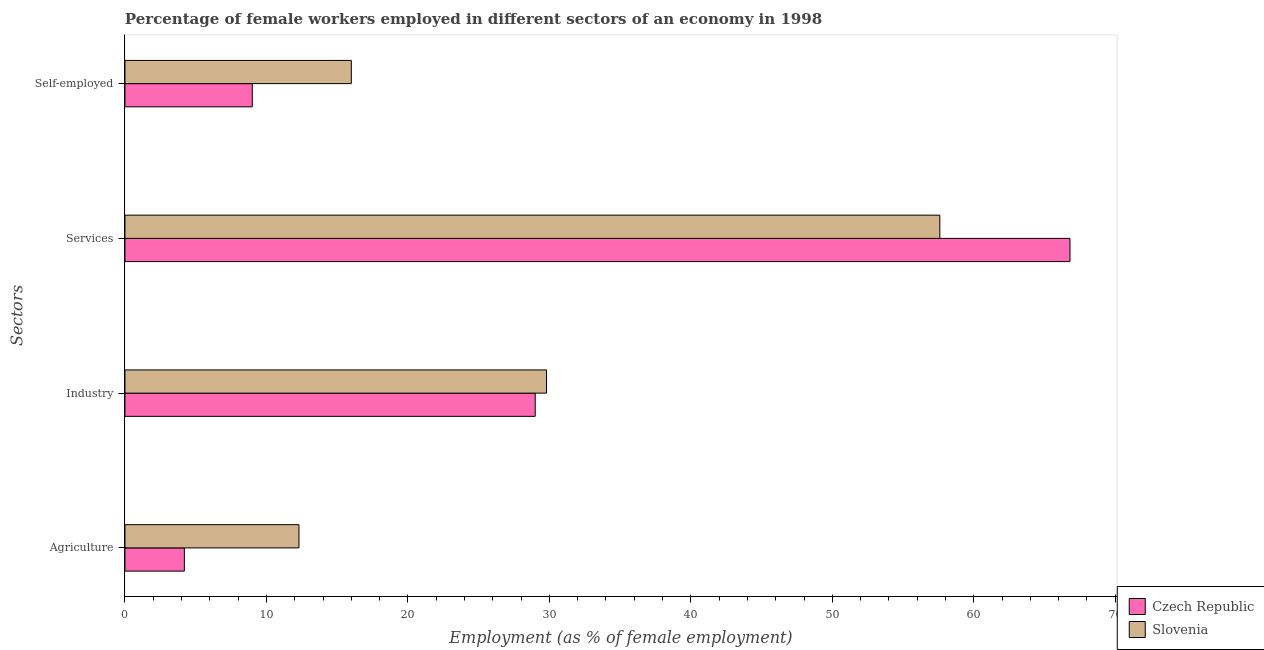How many groups of bars are there?
Offer a terse response. 4. How many bars are there on the 4th tick from the top?
Make the answer very short. 2. How many bars are there on the 3rd tick from the bottom?
Offer a terse response. 2. What is the label of the 4th group of bars from the top?
Make the answer very short. Agriculture. What is the percentage of self employed female workers in Czech Republic?
Your answer should be very brief. 9. Across all countries, what is the maximum percentage of self employed female workers?
Make the answer very short. 16. Across all countries, what is the minimum percentage of female workers in services?
Offer a very short reply. 57.6. In which country was the percentage of female workers in services maximum?
Keep it short and to the point. Czech Republic. In which country was the percentage of female workers in services minimum?
Provide a succinct answer. Slovenia. What is the total percentage of female workers in services in the graph?
Ensure brevity in your answer.  124.4. What is the difference between the percentage of female workers in industry in Slovenia and that in Czech Republic?
Offer a very short reply. 0.8. What is the difference between the percentage of female workers in industry in Czech Republic and the percentage of female workers in agriculture in Slovenia?
Your response must be concise. 16.7. What is the average percentage of self employed female workers per country?
Ensure brevity in your answer.  12.5. What is the difference between the percentage of female workers in industry and percentage of female workers in agriculture in Slovenia?
Provide a succinct answer. 17.5. What is the ratio of the percentage of female workers in industry in Czech Republic to that in Slovenia?
Offer a terse response. 0.97. Is the difference between the percentage of female workers in services in Slovenia and Czech Republic greater than the difference between the percentage of female workers in industry in Slovenia and Czech Republic?
Keep it short and to the point. No. What is the difference between the highest and the second highest percentage of female workers in agriculture?
Your answer should be very brief. 8.1. What is the difference between the highest and the lowest percentage of female workers in services?
Your answer should be compact. 9.2. What does the 2nd bar from the top in Services represents?
Ensure brevity in your answer.  Czech Republic. What does the 2nd bar from the bottom in Agriculture represents?
Your answer should be very brief. Slovenia. Is it the case that in every country, the sum of the percentage of female workers in agriculture and percentage of female workers in industry is greater than the percentage of female workers in services?
Make the answer very short. No. Are all the bars in the graph horizontal?
Offer a very short reply. Yes. Are the values on the major ticks of X-axis written in scientific E-notation?
Ensure brevity in your answer.  No. Does the graph contain any zero values?
Make the answer very short. No. Does the graph contain grids?
Keep it short and to the point. No. How are the legend labels stacked?
Keep it short and to the point. Vertical. What is the title of the graph?
Give a very brief answer. Percentage of female workers employed in different sectors of an economy in 1998. Does "Belize" appear as one of the legend labels in the graph?
Make the answer very short. No. What is the label or title of the X-axis?
Ensure brevity in your answer.  Employment (as % of female employment). What is the label or title of the Y-axis?
Provide a succinct answer. Sectors. What is the Employment (as % of female employment) of Czech Republic in Agriculture?
Offer a terse response. 4.2. What is the Employment (as % of female employment) in Slovenia in Agriculture?
Give a very brief answer. 12.3. What is the Employment (as % of female employment) of Czech Republic in Industry?
Make the answer very short. 29. What is the Employment (as % of female employment) in Slovenia in Industry?
Offer a terse response. 29.8. What is the Employment (as % of female employment) of Czech Republic in Services?
Offer a very short reply. 66.8. What is the Employment (as % of female employment) in Slovenia in Services?
Make the answer very short. 57.6. What is the Employment (as % of female employment) in Czech Republic in Self-employed?
Make the answer very short. 9. Across all Sectors, what is the maximum Employment (as % of female employment) in Czech Republic?
Your answer should be compact. 66.8. Across all Sectors, what is the maximum Employment (as % of female employment) in Slovenia?
Make the answer very short. 57.6. Across all Sectors, what is the minimum Employment (as % of female employment) in Czech Republic?
Provide a short and direct response. 4.2. Across all Sectors, what is the minimum Employment (as % of female employment) in Slovenia?
Your response must be concise. 12.3. What is the total Employment (as % of female employment) in Czech Republic in the graph?
Make the answer very short. 109. What is the total Employment (as % of female employment) of Slovenia in the graph?
Your response must be concise. 115.7. What is the difference between the Employment (as % of female employment) in Czech Republic in Agriculture and that in Industry?
Offer a terse response. -24.8. What is the difference between the Employment (as % of female employment) in Slovenia in Agriculture and that in Industry?
Keep it short and to the point. -17.5. What is the difference between the Employment (as % of female employment) in Czech Republic in Agriculture and that in Services?
Provide a short and direct response. -62.6. What is the difference between the Employment (as % of female employment) of Slovenia in Agriculture and that in Services?
Your answer should be very brief. -45.3. What is the difference between the Employment (as % of female employment) of Czech Republic in Agriculture and that in Self-employed?
Offer a very short reply. -4.8. What is the difference between the Employment (as % of female employment) in Czech Republic in Industry and that in Services?
Make the answer very short. -37.8. What is the difference between the Employment (as % of female employment) in Slovenia in Industry and that in Services?
Your response must be concise. -27.8. What is the difference between the Employment (as % of female employment) in Czech Republic in Industry and that in Self-employed?
Offer a terse response. 20. What is the difference between the Employment (as % of female employment) in Slovenia in Industry and that in Self-employed?
Your answer should be compact. 13.8. What is the difference between the Employment (as % of female employment) in Czech Republic in Services and that in Self-employed?
Offer a terse response. 57.8. What is the difference between the Employment (as % of female employment) of Slovenia in Services and that in Self-employed?
Provide a succinct answer. 41.6. What is the difference between the Employment (as % of female employment) of Czech Republic in Agriculture and the Employment (as % of female employment) of Slovenia in Industry?
Give a very brief answer. -25.6. What is the difference between the Employment (as % of female employment) of Czech Republic in Agriculture and the Employment (as % of female employment) of Slovenia in Services?
Offer a terse response. -53.4. What is the difference between the Employment (as % of female employment) in Czech Republic in Agriculture and the Employment (as % of female employment) in Slovenia in Self-employed?
Your answer should be very brief. -11.8. What is the difference between the Employment (as % of female employment) of Czech Republic in Industry and the Employment (as % of female employment) of Slovenia in Services?
Your response must be concise. -28.6. What is the difference between the Employment (as % of female employment) in Czech Republic in Services and the Employment (as % of female employment) in Slovenia in Self-employed?
Provide a succinct answer. 50.8. What is the average Employment (as % of female employment) in Czech Republic per Sectors?
Offer a very short reply. 27.25. What is the average Employment (as % of female employment) in Slovenia per Sectors?
Give a very brief answer. 28.93. What is the difference between the Employment (as % of female employment) of Czech Republic and Employment (as % of female employment) of Slovenia in Industry?
Your answer should be compact. -0.8. What is the ratio of the Employment (as % of female employment) of Czech Republic in Agriculture to that in Industry?
Keep it short and to the point. 0.14. What is the ratio of the Employment (as % of female employment) in Slovenia in Agriculture to that in Industry?
Ensure brevity in your answer.  0.41. What is the ratio of the Employment (as % of female employment) in Czech Republic in Agriculture to that in Services?
Offer a very short reply. 0.06. What is the ratio of the Employment (as % of female employment) of Slovenia in Agriculture to that in Services?
Offer a very short reply. 0.21. What is the ratio of the Employment (as % of female employment) in Czech Republic in Agriculture to that in Self-employed?
Keep it short and to the point. 0.47. What is the ratio of the Employment (as % of female employment) of Slovenia in Agriculture to that in Self-employed?
Make the answer very short. 0.77. What is the ratio of the Employment (as % of female employment) in Czech Republic in Industry to that in Services?
Your answer should be compact. 0.43. What is the ratio of the Employment (as % of female employment) of Slovenia in Industry to that in Services?
Your answer should be very brief. 0.52. What is the ratio of the Employment (as % of female employment) of Czech Republic in Industry to that in Self-employed?
Offer a very short reply. 3.22. What is the ratio of the Employment (as % of female employment) in Slovenia in Industry to that in Self-employed?
Provide a succinct answer. 1.86. What is the ratio of the Employment (as % of female employment) of Czech Republic in Services to that in Self-employed?
Make the answer very short. 7.42. What is the difference between the highest and the second highest Employment (as % of female employment) of Czech Republic?
Your response must be concise. 37.8. What is the difference between the highest and the second highest Employment (as % of female employment) in Slovenia?
Keep it short and to the point. 27.8. What is the difference between the highest and the lowest Employment (as % of female employment) in Czech Republic?
Provide a short and direct response. 62.6. What is the difference between the highest and the lowest Employment (as % of female employment) in Slovenia?
Your response must be concise. 45.3. 